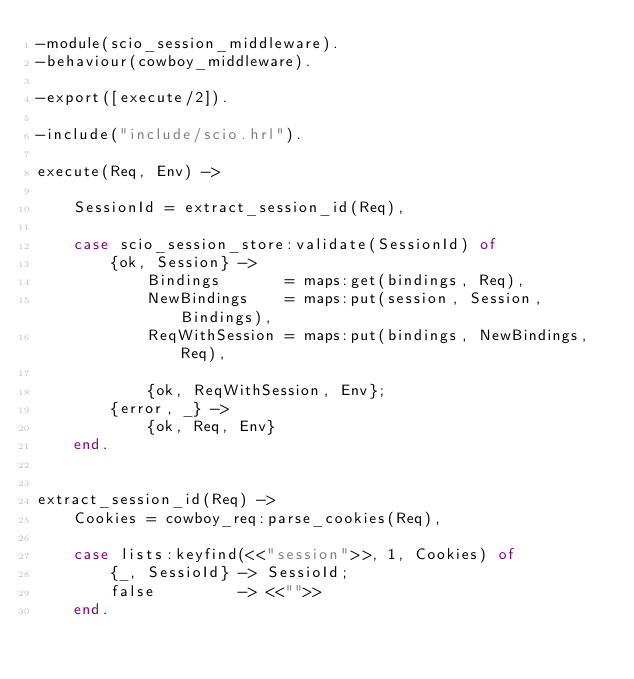<code> <loc_0><loc_0><loc_500><loc_500><_Erlang_>-module(scio_session_middleware).
-behaviour(cowboy_middleware).

-export([execute/2]).

-include("include/scio.hrl").

execute(Req, Env) ->

    SessionId = extract_session_id(Req),

    case scio_session_store:validate(SessionId) of
        {ok, Session} ->
            Bindings       = maps:get(bindings, Req),
            NewBindings    = maps:put(session, Session, Bindings),
            ReqWithSession = maps:put(bindings, NewBindings, Req),

            {ok, ReqWithSession, Env};
        {error, _} ->
            {ok, Req, Env}
    end.


extract_session_id(Req) ->
    Cookies = cowboy_req:parse_cookies(Req),

    case lists:keyfind(<<"session">>, 1, Cookies) of
        {_, SessioId} -> SessioId;
        false         -> <<"">>
    end.

</code> 